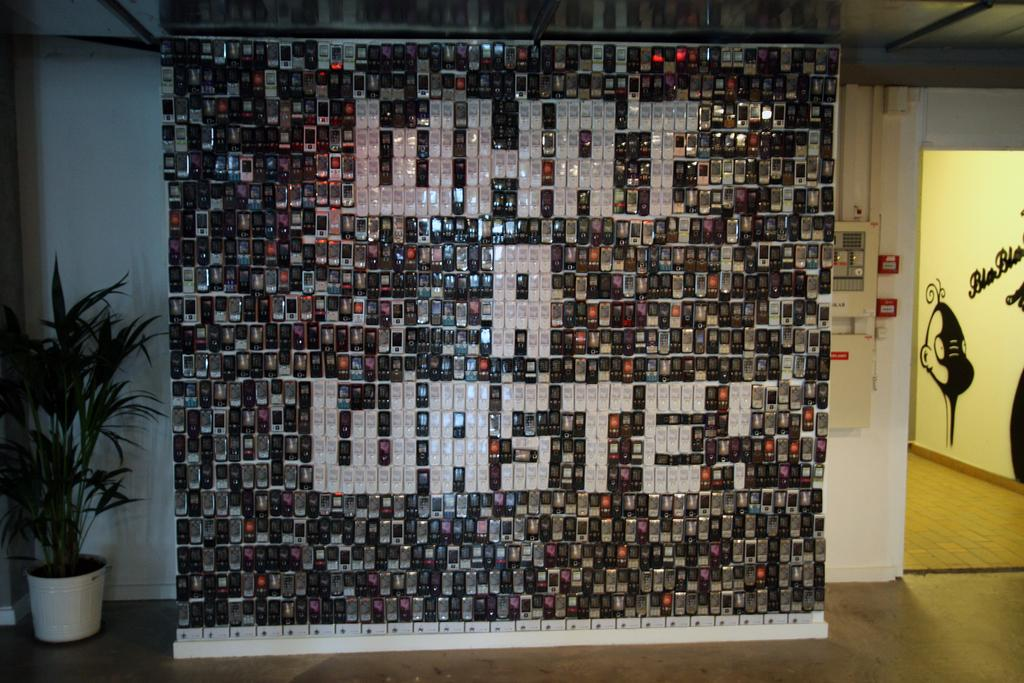<image>
Render a clear and concise summary of the photo. An wall art installation of used cell phones spelling out "What a Waste!". 